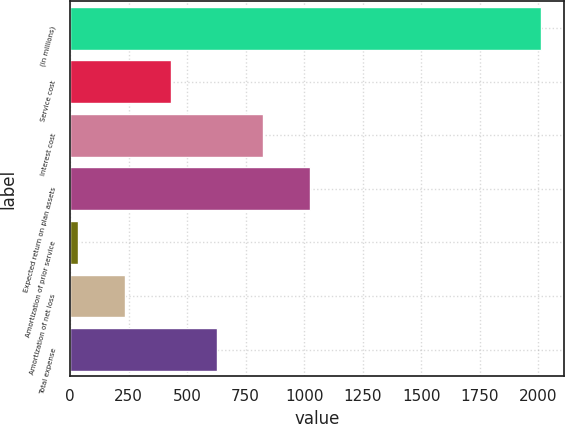Convert chart. <chart><loc_0><loc_0><loc_500><loc_500><bar_chart><fcel>(in millions)<fcel>Service cost<fcel>Interest cost<fcel>Expected return on plan assets<fcel>Amortization of prior service<fcel>Amortization of net loss<fcel>Total expense<nl><fcel>2012<fcel>430.4<fcel>825.8<fcel>1023.5<fcel>35<fcel>232.7<fcel>628.1<nl></chart> 